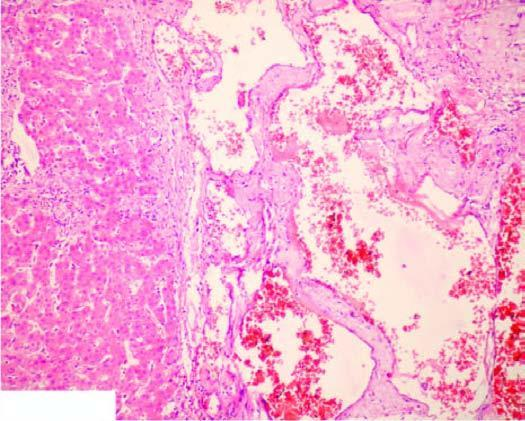what are the vascular spaces lined by?
Answer the question using a single word or phrase. Flattened endothelial cells 